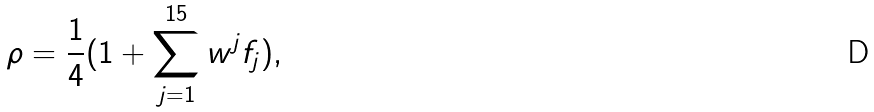Convert formula to latex. <formula><loc_0><loc_0><loc_500><loc_500>\rho = \frac { 1 } { 4 } ( 1 + \sum _ { j = 1 } ^ { 1 5 } w ^ { j } f _ { j } ) ,</formula> 